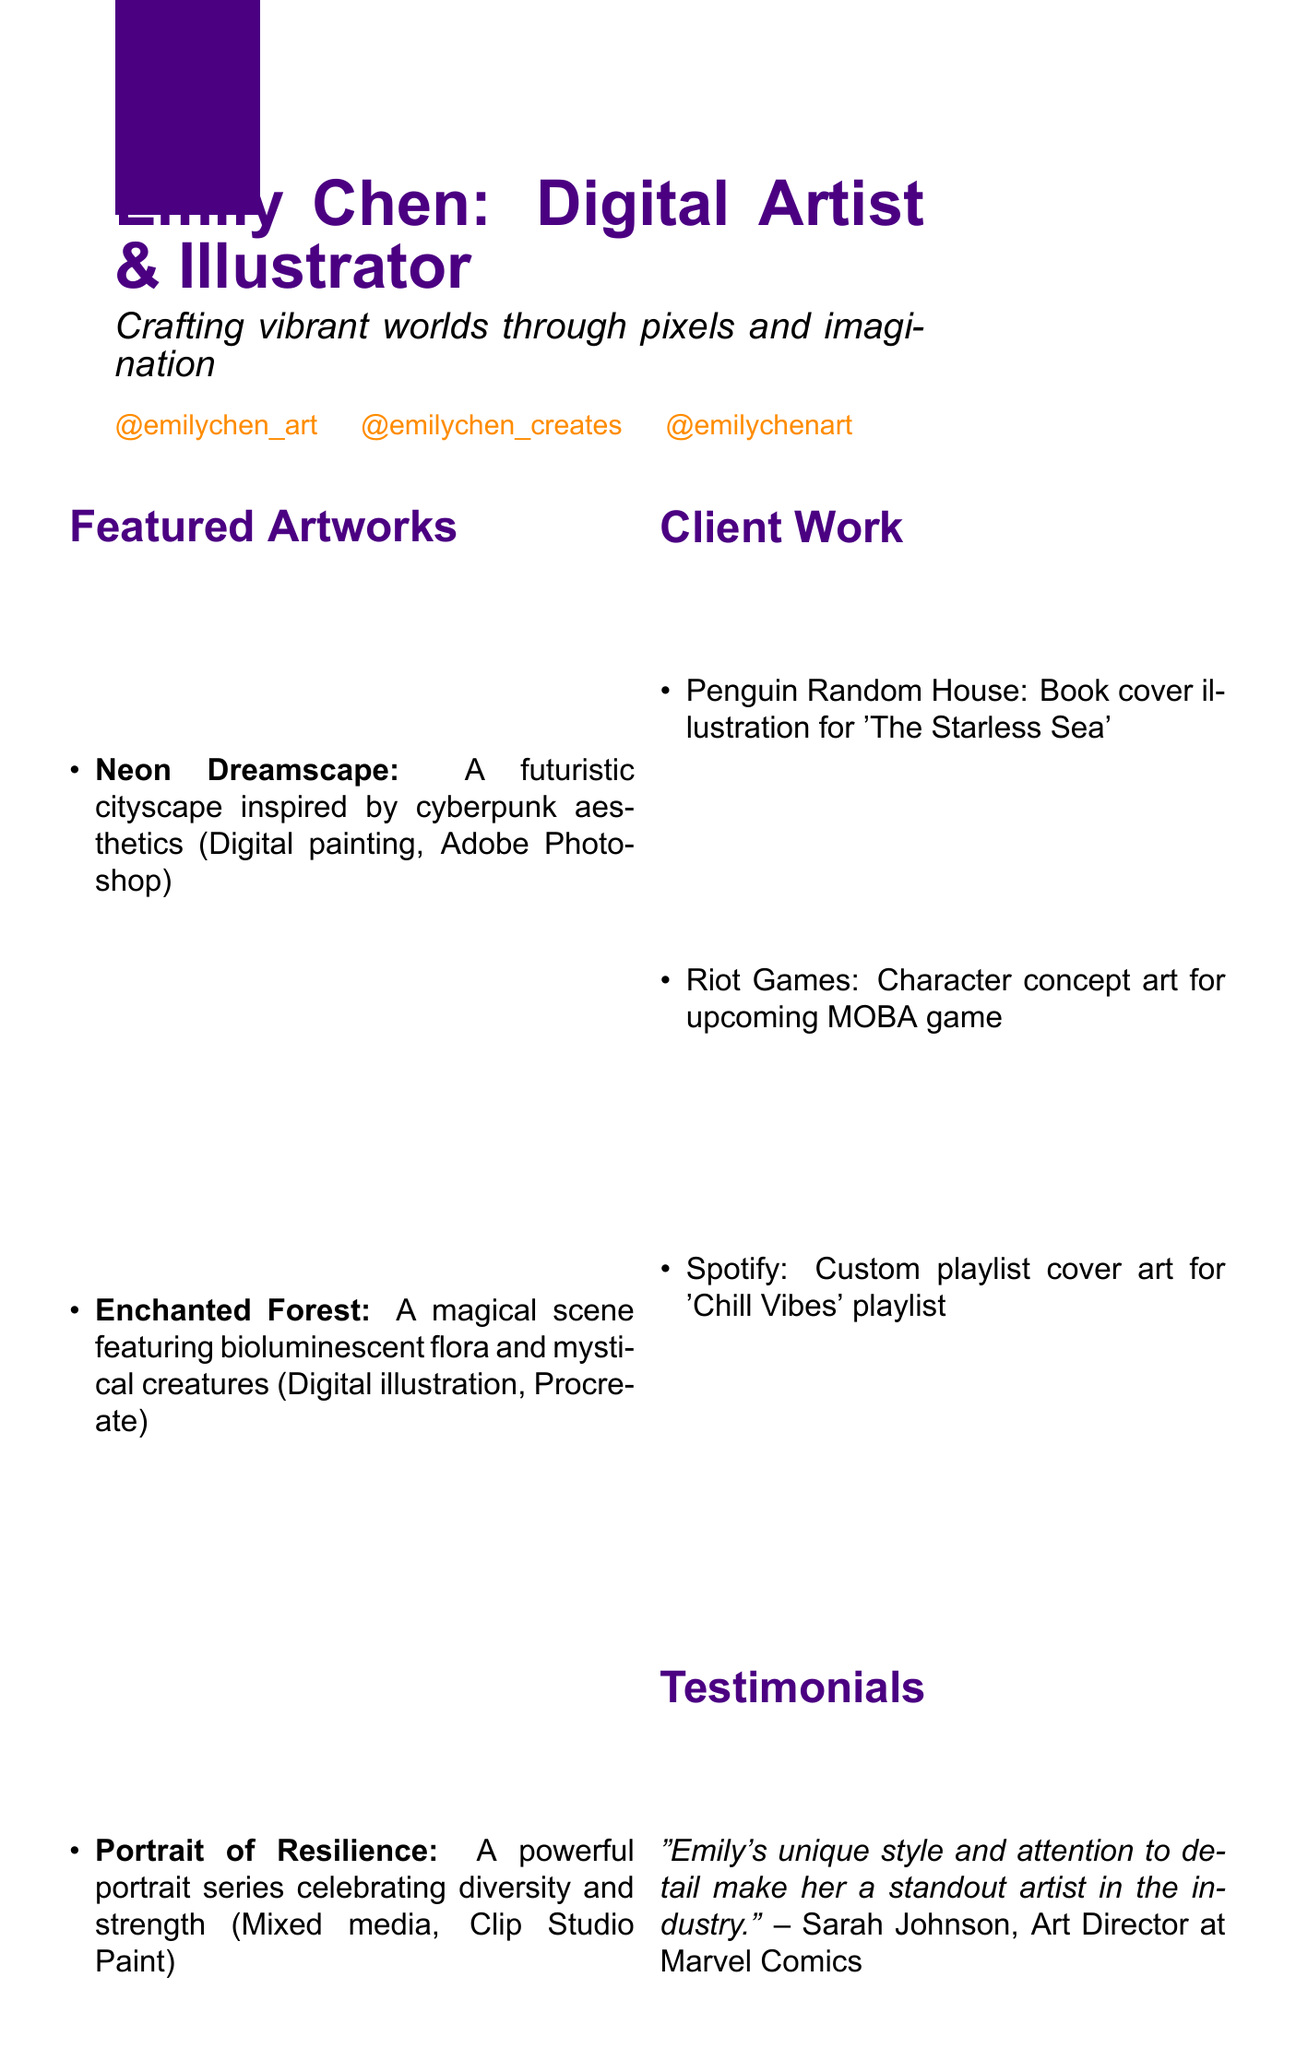What is the title of the portfolio? The title of the portfolio is explicitly stated in the header section as "Emily Chen: Digital Artist & Illustrator".
Answer: Emily Chen: Digital Artist & Illustrator What is the tagline associated with Emily's work? The tagline presents Emily's artistic focus and is listed right under the title: "Crafting vibrant worlds through pixels and imagination".
Answer: Crafting vibrant worlds through pixels and imagination How many featured artworks are included in the portfolio? The number of artworks is counted from the "Featured Artworks" section, which lists three specific items.
Answer: 3 What software is used for "Portrait of Resilience"? Each featured artwork lists the software used, specifically identifying "Clip Studio Paint" for this piece.
Answer: Clip Studio Paint Who is one of the clients mentioned in "Client Work"? The document lists "Penguin Random House" as one of the clients involved in a specific project.
Answer: Penguin Random House What type of media is "Enchanted Forest"? The medium used for the artwork is specified under the title in the "Featured Artworks" section: "Digital illustration".
Answer: Digital illustration What section provides updates and tips for artists? The "Blog" section is dedicated to regular updates and tips, as stated in its description.
Answer: Blog How can someone contact Emily for collaborations? The "Contact" section contains the email address provided for inquiries and collaborations.
Answer: emily@emilychen.art 